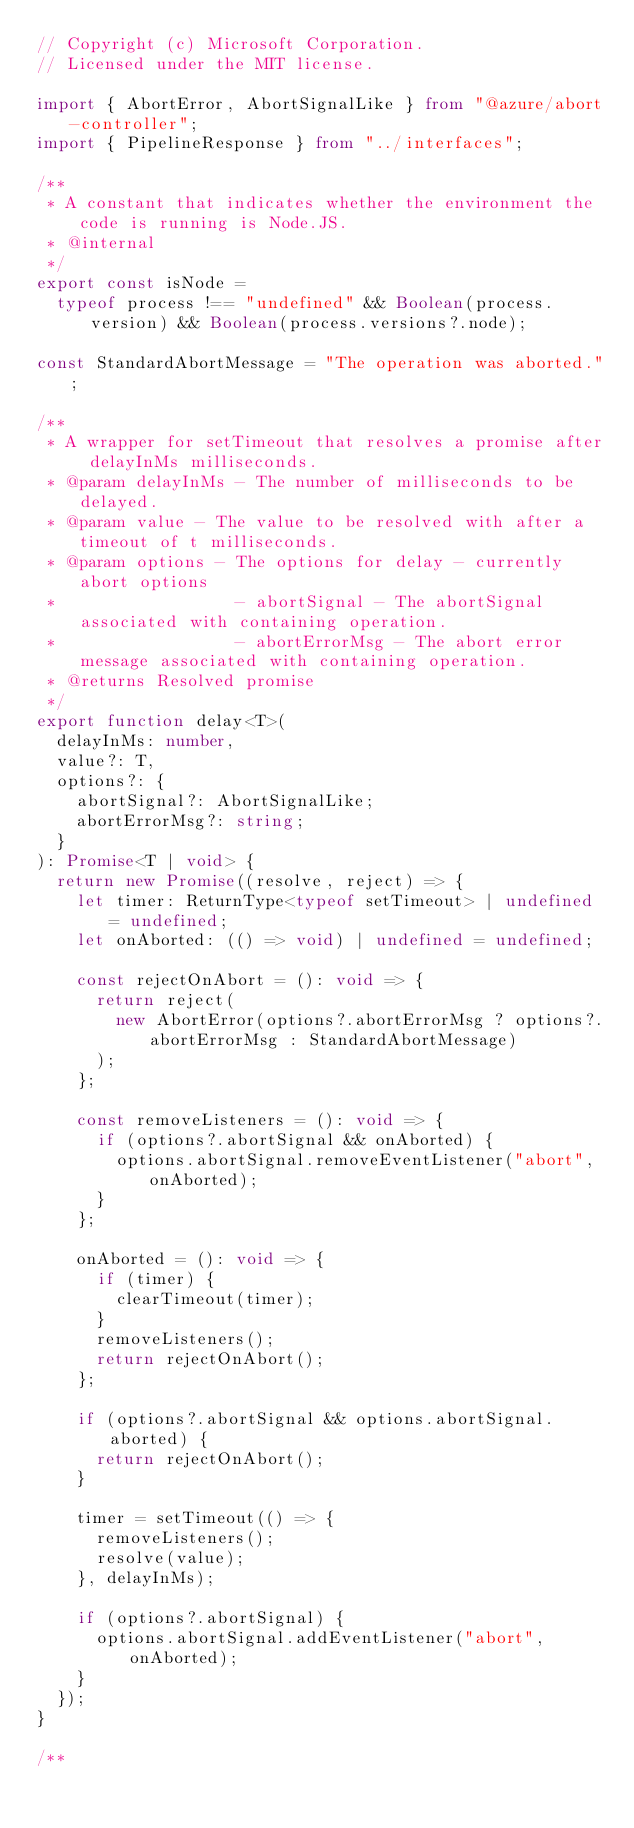<code> <loc_0><loc_0><loc_500><loc_500><_TypeScript_>// Copyright (c) Microsoft Corporation.
// Licensed under the MIT license.

import { AbortError, AbortSignalLike } from "@azure/abort-controller";
import { PipelineResponse } from "../interfaces";

/**
 * A constant that indicates whether the environment the code is running is Node.JS.
 * @internal
 */
export const isNode =
  typeof process !== "undefined" && Boolean(process.version) && Boolean(process.versions?.node);

const StandardAbortMessage = "The operation was aborted.";

/**
 * A wrapper for setTimeout that resolves a promise after delayInMs milliseconds.
 * @param delayInMs - The number of milliseconds to be delayed.
 * @param value - The value to be resolved with after a timeout of t milliseconds.
 * @param options - The options for delay - currently abort options
 *                  - abortSignal - The abortSignal associated with containing operation.
 *                  - abortErrorMsg - The abort error message associated with containing operation.
 * @returns Resolved promise
 */
export function delay<T>(
  delayInMs: number,
  value?: T,
  options?: {
    abortSignal?: AbortSignalLike;
    abortErrorMsg?: string;
  }
): Promise<T | void> {
  return new Promise((resolve, reject) => {
    let timer: ReturnType<typeof setTimeout> | undefined = undefined;
    let onAborted: (() => void) | undefined = undefined;

    const rejectOnAbort = (): void => {
      return reject(
        new AbortError(options?.abortErrorMsg ? options?.abortErrorMsg : StandardAbortMessage)
      );
    };

    const removeListeners = (): void => {
      if (options?.abortSignal && onAborted) {
        options.abortSignal.removeEventListener("abort", onAborted);
      }
    };

    onAborted = (): void => {
      if (timer) {
        clearTimeout(timer);
      }
      removeListeners();
      return rejectOnAbort();
    };

    if (options?.abortSignal && options.abortSignal.aborted) {
      return rejectOnAbort();
    }

    timer = setTimeout(() => {
      removeListeners();
      resolve(value);
    }, delayInMs);

    if (options?.abortSignal) {
      options.abortSignal.addEventListener("abort", onAborted);
    }
  });
}

/**</code> 